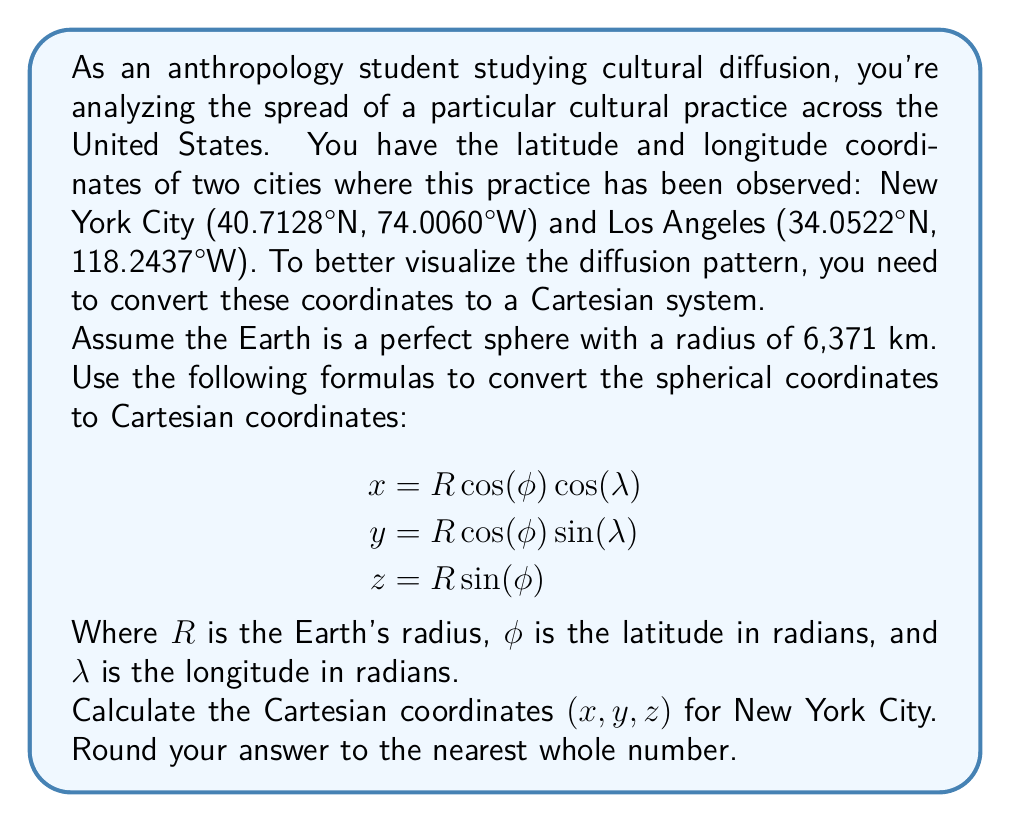Provide a solution to this math problem. Let's approach this step-by-step:

1) First, we need to convert the latitude and longitude from degrees to radians:
   $\phi = 40.7128° \times \frac{\pi}{180} = 0.7103$ radians
   $\lambda = -74.0060° \times \frac{\pi}{180} = -1.2917$ radians
   (Note: We use negative for western longitude)

2) Now, let's plug these values into our equations:
   $R = 6371$ km (given)
   $\phi = 0.7103$ radians
   $\lambda = -1.2917$ radians

3) Calculate x:
   $$x = R \cos(\phi) \cos(\lambda)$$
   $$x = 6371 \times \cos(0.7103) \times \cos(-1.2917)$$
   $$x = 6371 \times 0.7558 \times 0.2740$$
   $$x = 1320.81$$

4) Calculate y:
   $$y = R \cos(\phi) \sin(\lambda)$$
   $$y = 6371 \times \cos(0.7103) \times \sin(-1.2917)$$
   $$y = 6371 \times 0.7558 \times (-0.9617)$$
   $$y = -4635.76$$

5) Calculate z:
   $$z = R \sin(\phi)$$
   $$z = 6371 \times \sin(0.7103)$$
   $$z = 6371 \times 0.6548$$
   $$z = 4171.56$$

6) Rounding to the nearest whole number:
   x ≈ 1321
   y ≈ -4636
   z ≈ 4172
Answer: (1321, -4636, 4172) 